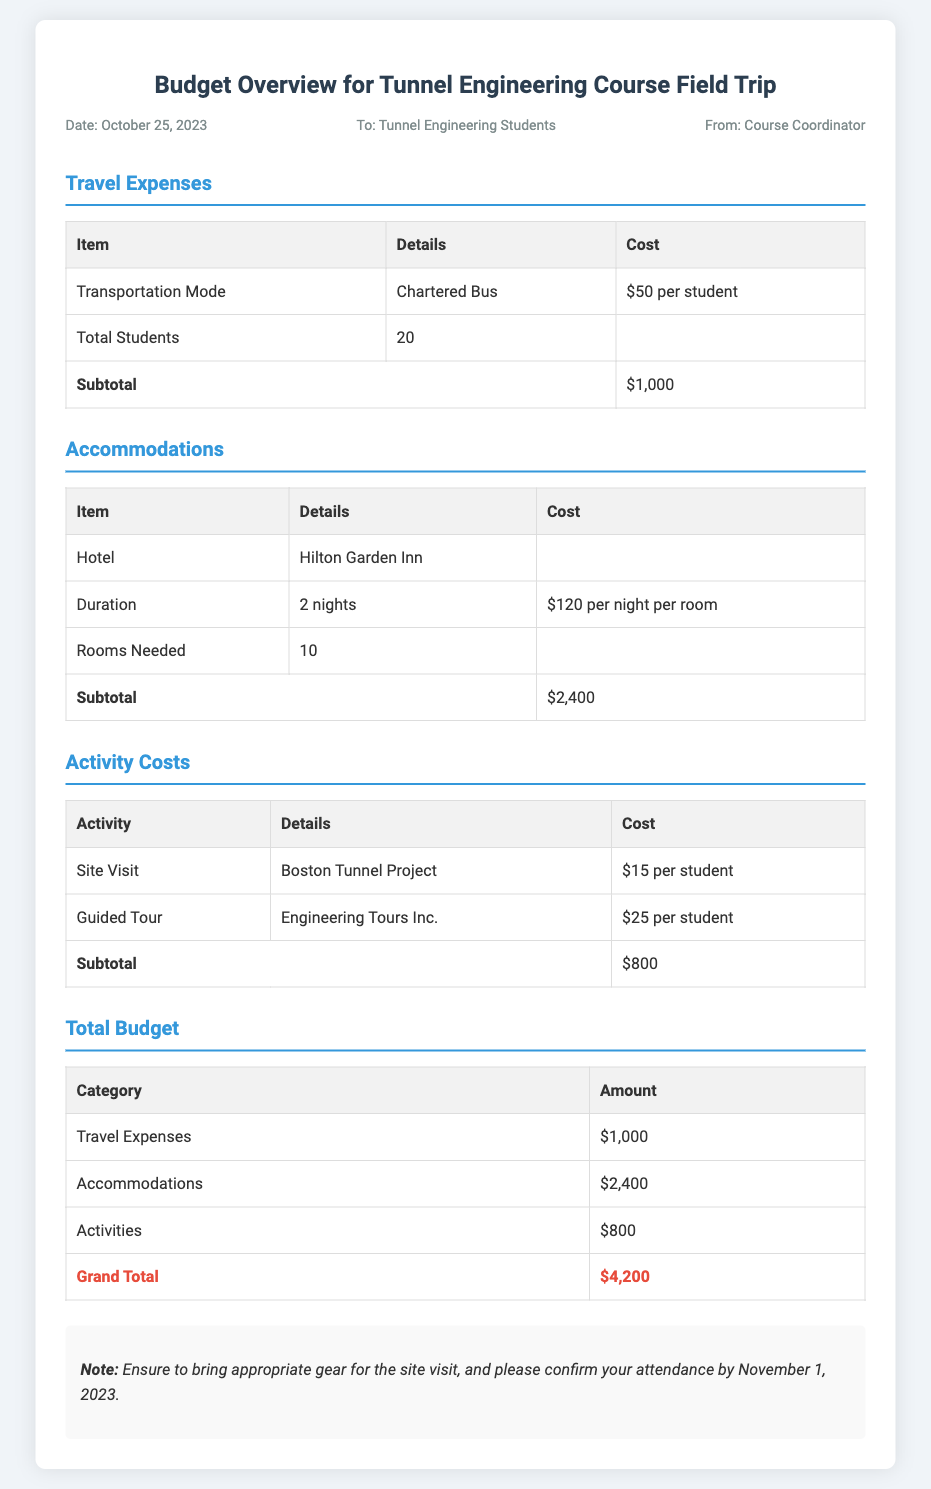What is the date of the memo? The date of the memo is mentioned at the top as October 25, 2023.
Answer: October 25, 2023 How much is the transportation mode cost per student? The transportation mode cost per student is listed under Travel Expenses as $50.
Answer: $50 How many students are participating in the trip? The total number of students is specified in the Travel Expenses section as 20.
Answer: 20 What is the total accommodation cost? The total accommodation cost is provided in the Accommodations section as $2,400.
Answer: $2,400 What is the total budget for the trip? The total budget, including travel expenses, accommodations, and activities, is presented as $4,200 in the Total Budget section.
Answer: $4,200 How many nights will the students stay at the hotel? The duration of the hotel stay is indicated as 2 nights in the Accommodations section.
Answer: 2 nights Which company is providing the guided tour? The guided tour is provided by Engineering Tours Inc., mentioned in the Activity Costs section.
Answer: Engineering Tours Inc What is the subtotal for activity costs? The subtotal for activity costs is indicated in the Activity Costs section as $800.
Answer: $800 What should students confirm by November 1, 2023? The memo notes that students should confirm their attendance by the specified date.
Answer: Attendance 